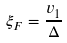<formula> <loc_0><loc_0><loc_500><loc_500>\xi _ { F } = \frac { v _ { 1 } } { \Delta }</formula> 